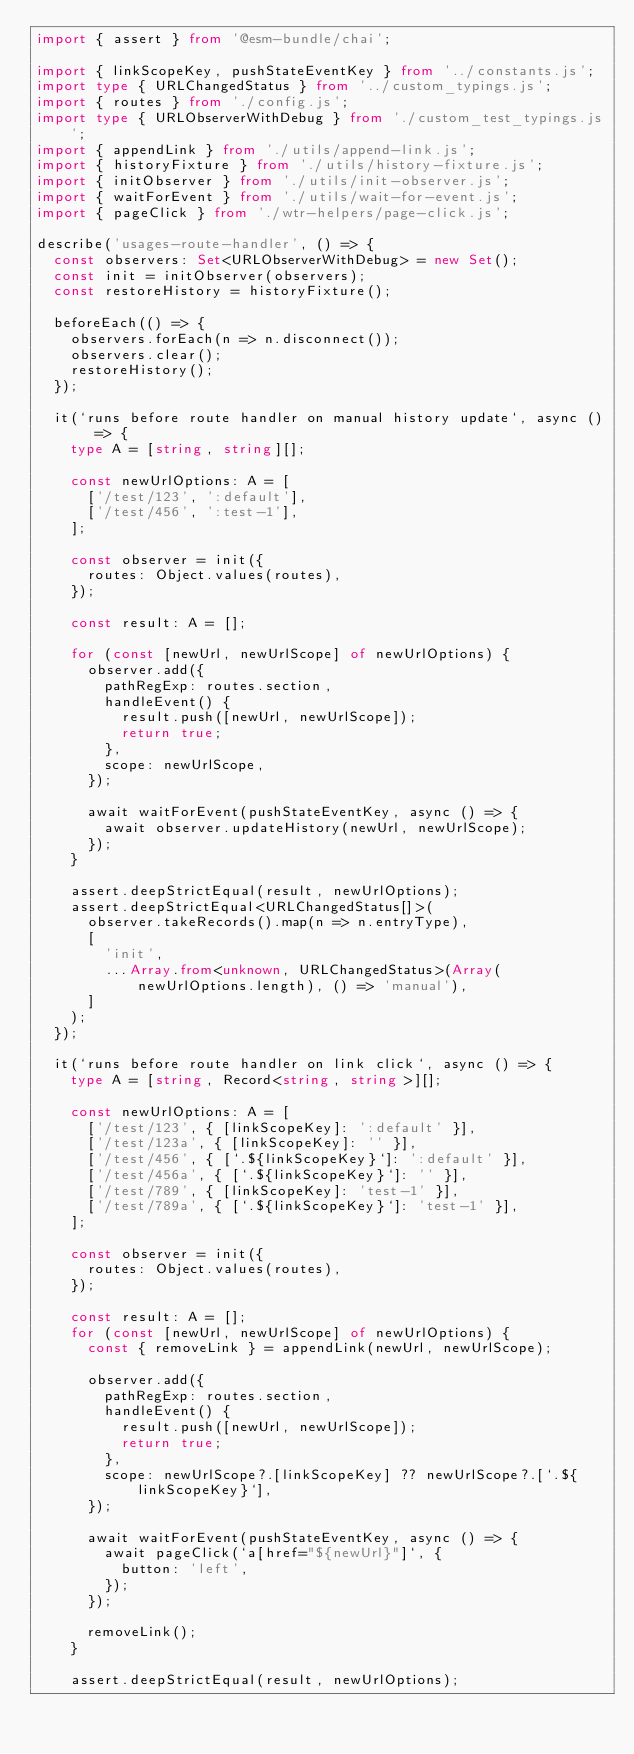Convert code to text. <code><loc_0><loc_0><loc_500><loc_500><_TypeScript_>import { assert } from '@esm-bundle/chai';

import { linkScopeKey, pushStateEventKey } from '../constants.js';
import type { URLChangedStatus } from '../custom_typings.js';
import { routes } from './config.js';
import type { URLObserverWithDebug } from './custom_test_typings.js';
import { appendLink } from './utils/append-link.js';
import { historyFixture } from './utils/history-fixture.js';
import { initObserver } from './utils/init-observer.js';
import { waitForEvent } from './utils/wait-for-event.js';
import { pageClick } from './wtr-helpers/page-click.js';

describe('usages-route-handler', () => {
  const observers: Set<URLObserverWithDebug> = new Set();
  const init = initObserver(observers);
  const restoreHistory = historyFixture();

  beforeEach(() => {
    observers.forEach(n => n.disconnect());
    observers.clear();
    restoreHistory();
  });

  it(`runs before route handler on manual history update`, async () => {
    type A = [string, string][];

    const newUrlOptions: A = [
      ['/test/123', ':default'],
      ['/test/456', ':test-1'],
    ];

    const observer = init({
      routes: Object.values(routes),
    });

    const result: A = [];

    for (const [newUrl, newUrlScope] of newUrlOptions) {
      observer.add({
        pathRegExp: routes.section,
        handleEvent() {
          result.push([newUrl, newUrlScope]);
          return true;
        },
        scope: newUrlScope,
      });

      await waitForEvent(pushStateEventKey, async () => {
        await observer.updateHistory(newUrl, newUrlScope);
      });
    }

    assert.deepStrictEqual(result, newUrlOptions);
    assert.deepStrictEqual<URLChangedStatus[]>(
      observer.takeRecords().map(n => n.entryType),
      [
        'init',
        ...Array.from<unknown, URLChangedStatus>(Array(newUrlOptions.length), () => 'manual'),
      ]
    );
  });

  it(`runs before route handler on link click`, async () => {
    type A = [string, Record<string, string>][];

    const newUrlOptions: A = [
      ['/test/123', { [linkScopeKey]: ':default' }],
      ['/test/123a', { [linkScopeKey]: '' }],
      ['/test/456', { [`.${linkScopeKey}`]: ':default' }],
      ['/test/456a', { [`.${linkScopeKey}`]: '' }],
      ['/test/789', { [linkScopeKey]: 'test-1' }],
      ['/test/789a', { [`.${linkScopeKey}`]: 'test-1' }],
    ];

    const observer = init({
      routes: Object.values(routes),
    });

    const result: A = [];
    for (const [newUrl, newUrlScope] of newUrlOptions) {
      const { removeLink } = appendLink(newUrl, newUrlScope);

      observer.add({
        pathRegExp: routes.section,
        handleEvent() {
          result.push([newUrl, newUrlScope]);
          return true;
        },
        scope: newUrlScope?.[linkScopeKey] ?? newUrlScope?.[`.${linkScopeKey}`],
      });

      await waitForEvent(pushStateEventKey, async () => {
        await pageClick(`a[href="${newUrl}"]`, {
          button: 'left',
        });
      });

      removeLink();
    }

    assert.deepStrictEqual(result, newUrlOptions);</code> 